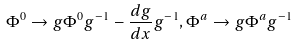<formula> <loc_0><loc_0><loc_500><loc_500>\Phi ^ { 0 } \to g \Phi ^ { 0 } g ^ { - 1 } - \frac { d g } { d x } g ^ { - 1 } , \Phi ^ { a } \to g \Phi ^ { a } g ^ { - 1 }</formula> 